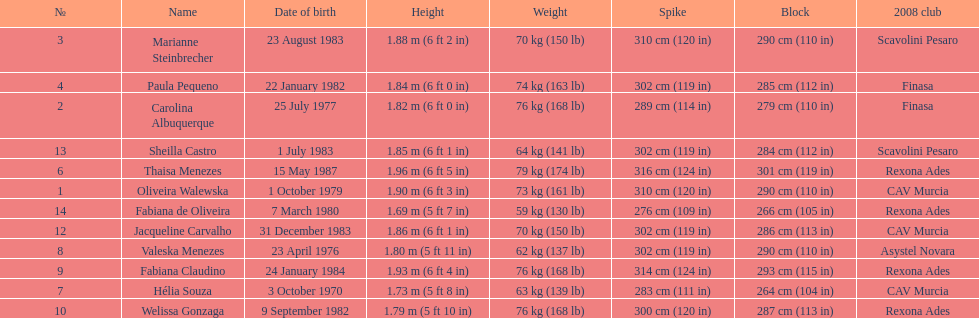Oliveira walewska has the same block as how many other players? 2. Give me the full table as a dictionary. {'header': ['№', 'Name', 'Date of birth', 'Height', 'Weight', 'Spike', 'Block', '2008 club'], 'rows': [['3', 'Marianne Steinbrecher', '23 August 1983', '1.88\xa0m (6\xa0ft 2\xa0in)', '70\xa0kg (150\xa0lb)', '310\xa0cm (120\xa0in)', '290\xa0cm (110\xa0in)', 'Scavolini Pesaro'], ['4', 'Paula Pequeno', '22 January 1982', '1.84\xa0m (6\xa0ft 0\xa0in)', '74\xa0kg (163\xa0lb)', '302\xa0cm (119\xa0in)', '285\xa0cm (112\xa0in)', 'Finasa'], ['2', 'Carolina Albuquerque', '25 July 1977', '1.82\xa0m (6\xa0ft 0\xa0in)', '76\xa0kg (168\xa0lb)', '289\xa0cm (114\xa0in)', '279\xa0cm (110\xa0in)', 'Finasa'], ['13', 'Sheilla Castro', '1 July 1983', '1.85\xa0m (6\xa0ft 1\xa0in)', '64\xa0kg (141\xa0lb)', '302\xa0cm (119\xa0in)', '284\xa0cm (112\xa0in)', 'Scavolini Pesaro'], ['6', 'Thaisa Menezes', '15 May 1987', '1.96\xa0m (6\xa0ft 5\xa0in)', '79\xa0kg (174\xa0lb)', '316\xa0cm (124\xa0in)', '301\xa0cm (119\xa0in)', 'Rexona Ades'], ['1', 'Oliveira Walewska', '1 October 1979', '1.90\xa0m (6\xa0ft 3\xa0in)', '73\xa0kg (161\xa0lb)', '310\xa0cm (120\xa0in)', '290\xa0cm (110\xa0in)', 'CAV Murcia'], ['14', 'Fabiana de Oliveira', '7 March 1980', '1.69\xa0m (5\xa0ft 7\xa0in)', '59\xa0kg (130\xa0lb)', '276\xa0cm (109\xa0in)', '266\xa0cm (105\xa0in)', 'Rexona Ades'], ['12', 'Jacqueline Carvalho', '31 December 1983', '1.86\xa0m (6\xa0ft 1\xa0in)', '70\xa0kg (150\xa0lb)', '302\xa0cm (119\xa0in)', '286\xa0cm (113\xa0in)', 'CAV Murcia'], ['8', 'Valeska Menezes', '23 April 1976', '1.80\xa0m (5\xa0ft 11\xa0in)', '62\xa0kg (137\xa0lb)', '302\xa0cm (119\xa0in)', '290\xa0cm (110\xa0in)', 'Asystel Novara'], ['9', 'Fabiana Claudino', '24 January 1984', '1.93\xa0m (6\xa0ft 4\xa0in)', '76\xa0kg (168\xa0lb)', '314\xa0cm (124\xa0in)', '293\xa0cm (115\xa0in)', 'Rexona Ades'], ['7', 'Hélia Souza', '3 October 1970', '1.73\xa0m (5\xa0ft 8\xa0in)', '63\xa0kg (139\xa0lb)', '283\xa0cm (111\xa0in)', '264\xa0cm (104\xa0in)', 'CAV Murcia'], ['10', 'Welissa Gonzaga', '9 September 1982', '1.79\xa0m (5\xa0ft 10\xa0in)', '76\xa0kg (168\xa0lb)', '300\xa0cm (120\xa0in)', '287\xa0cm (113\xa0in)', 'Rexona Ades']]} 